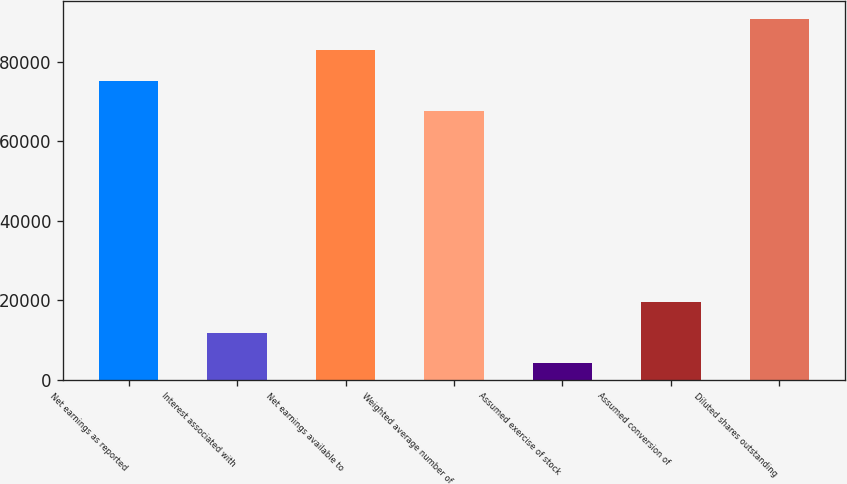Convert chart to OTSL. <chart><loc_0><loc_0><loc_500><loc_500><bar_chart><fcel>Net earnings as reported<fcel>Interest associated with<fcel>Net earnings available to<fcel>Weighted average number of<fcel>Assumed exercise of stock<fcel>Assumed conversion of<fcel>Diluted shares outstanding<nl><fcel>75268.9<fcel>11781.9<fcel>82971.8<fcel>67566<fcel>4079<fcel>19484.8<fcel>90674.7<nl></chart> 